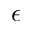<formula> <loc_0><loc_0><loc_500><loc_500>\epsilon</formula> 